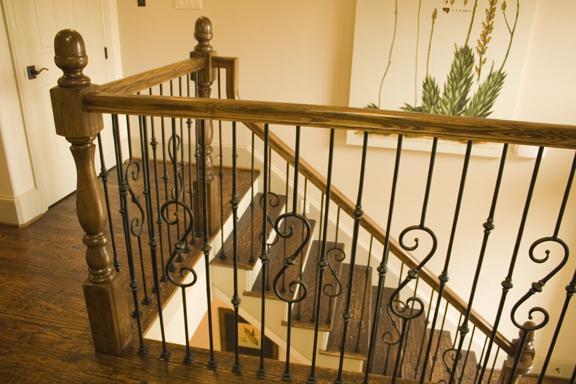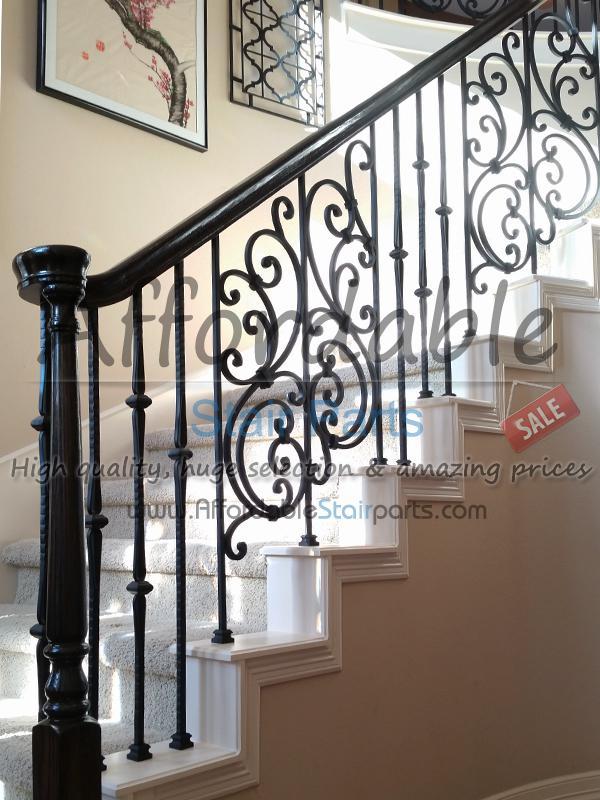The first image is the image on the left, the second image is the image on the right. For the images shown, is this caption "The right image shows a curved staircase with a brown wood handrail and black wrought iron bars with a scroll embellishment." true? Answer yes or no. No. The first image is the image on the left, the second image is the image on the right. Considering the images on both sides, is "The staircase in the image on the right winds down in a circular fashion." valid? Answer yes or no. No. 